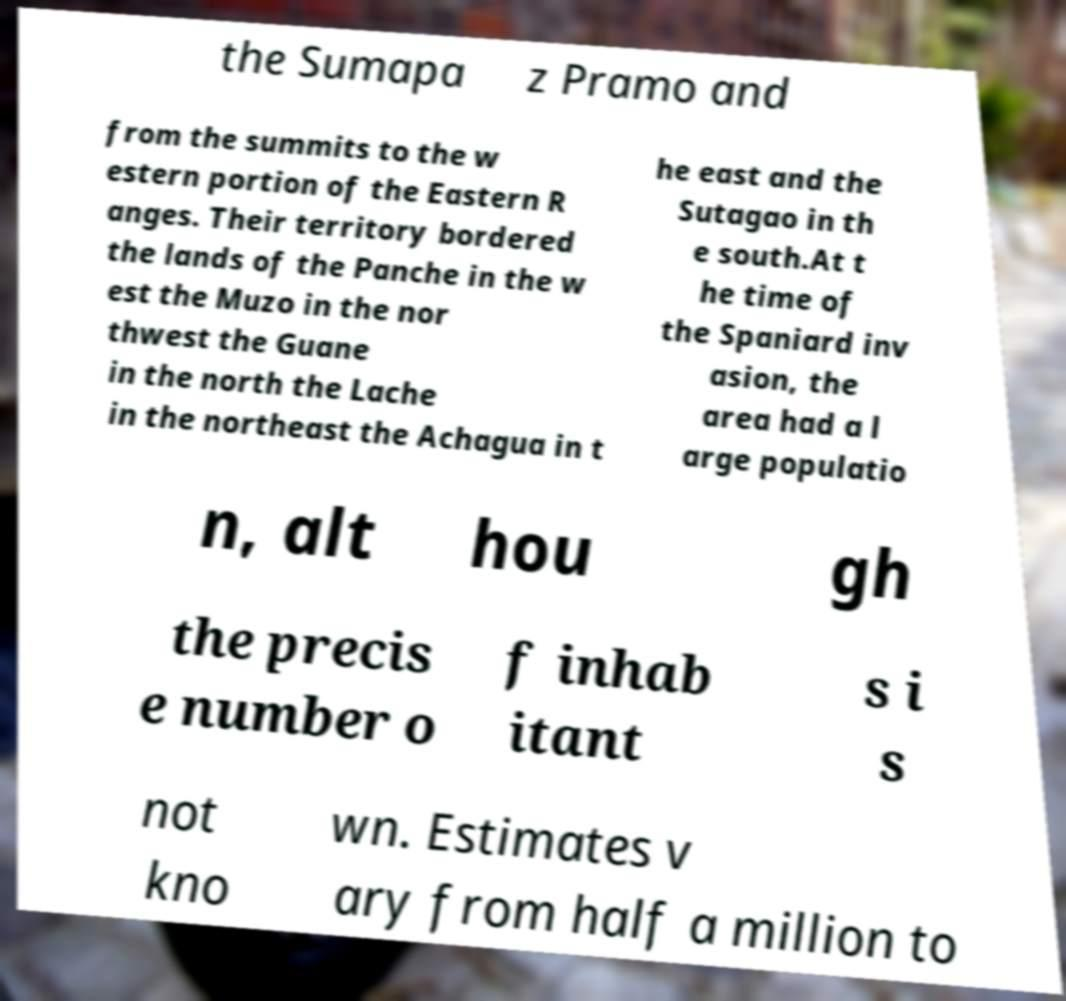Could you extract and type out the text from this image? the Sumapa z Pramo and from the summits to the w estern portion of the Eastern R anges. Their territory bordered the lands of the Panche in the w est the Muzo in the nor thwest the Guane in the north the Lache in the northeast the Achagua in t he east and the Sutagao in th e south.At t he time of the Spaniard inv asion, the area had a l arge populatio n, alt hou gh the precis e number o f inhab itant s i s not kno wn. Estimates v ary from half a million to 